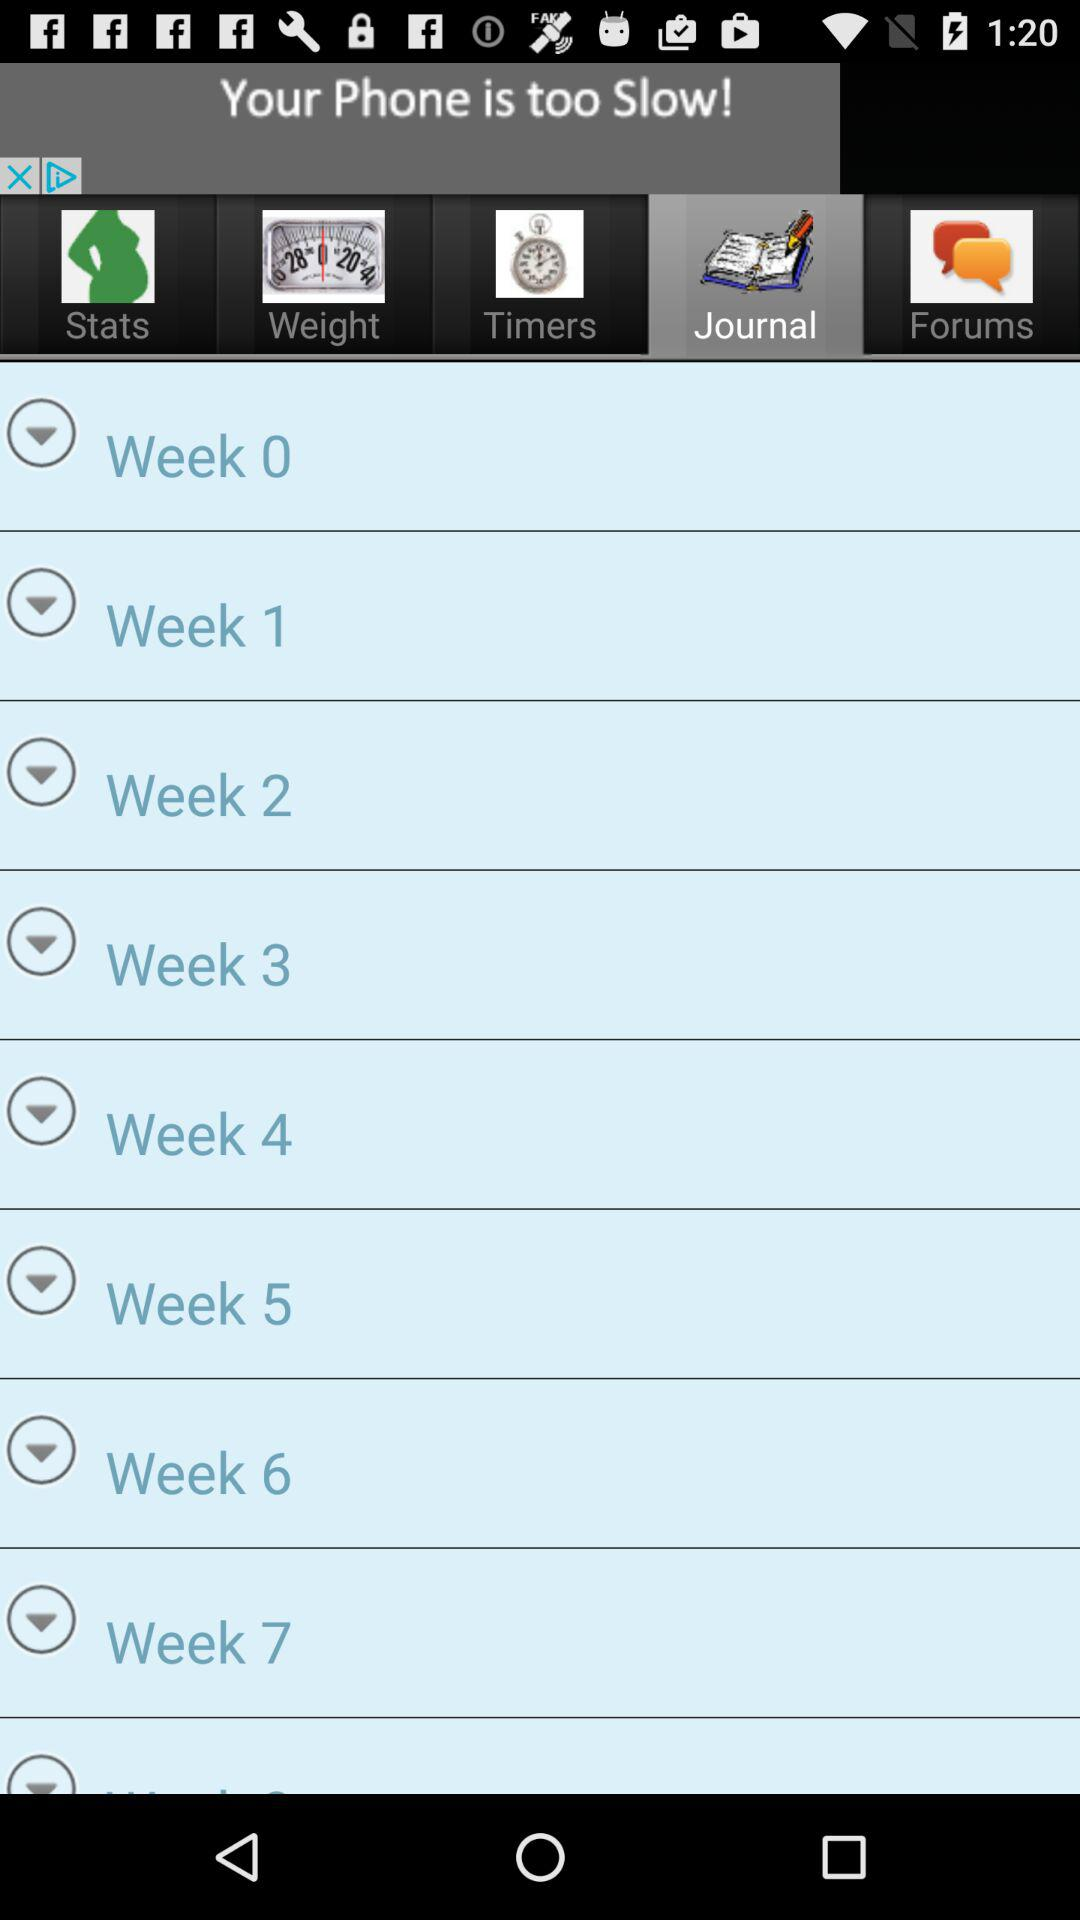Which option is selected? The selected option is "Journal". 